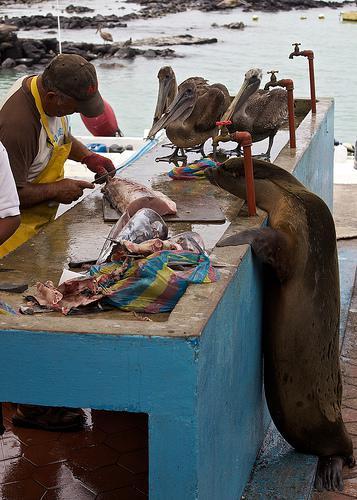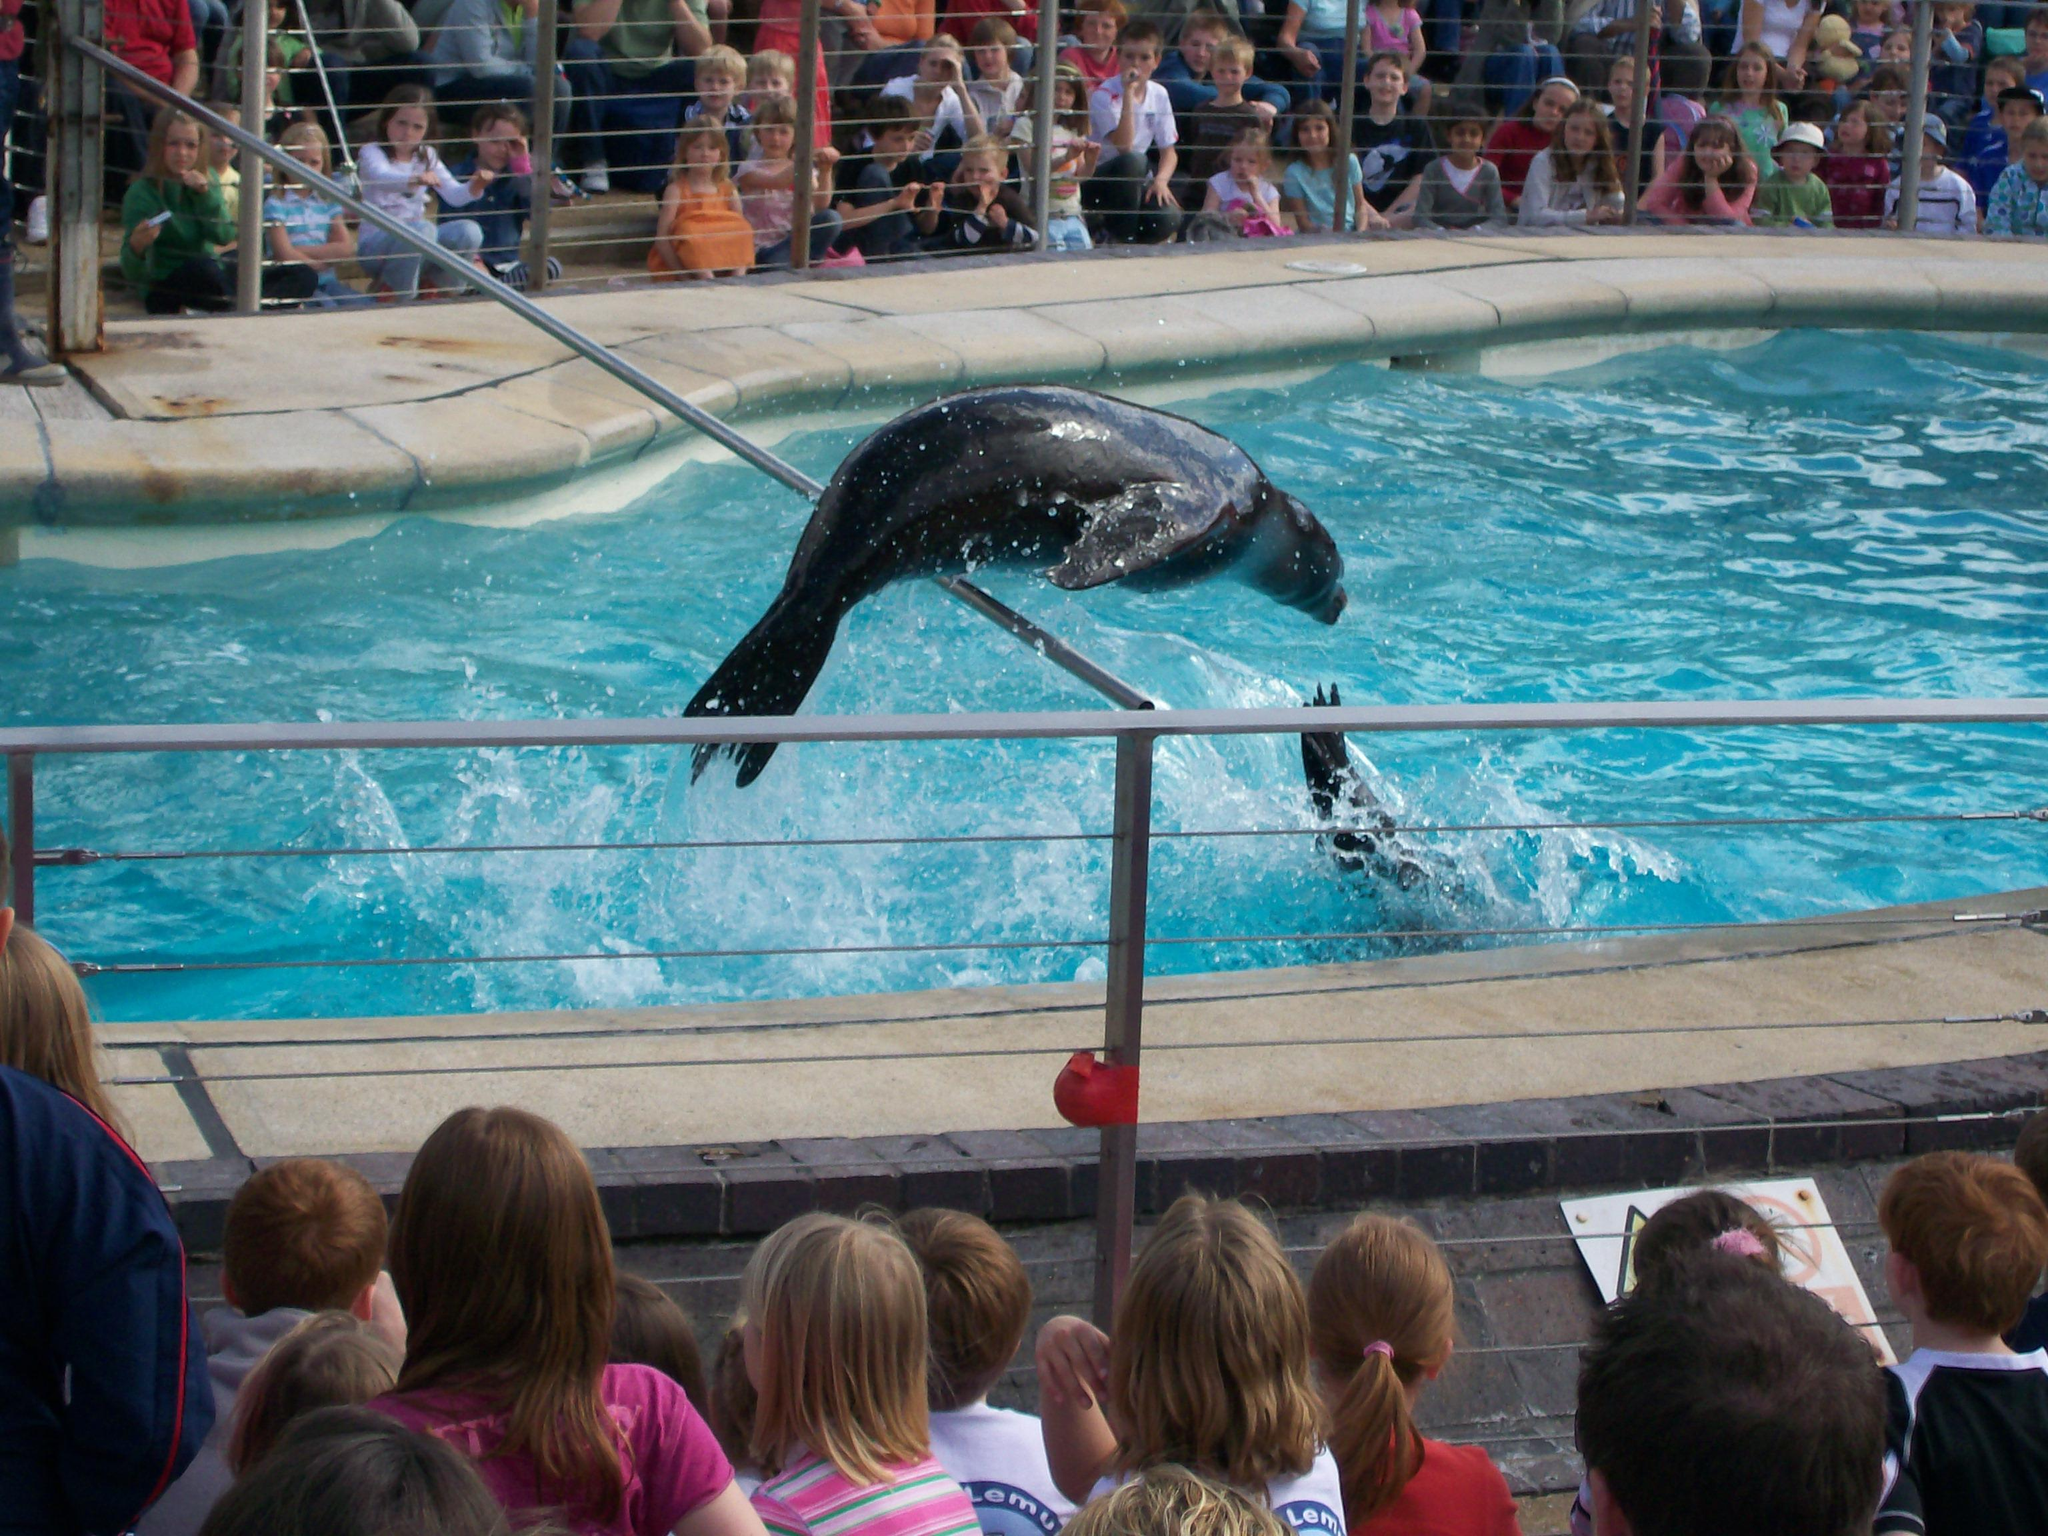The first image is the image on the left, the second image is the image on the right. Assess this claim about the two images: "Each image shows a seal performing in a show, and one image shows a seal balancing on a stone ledge with at least part of its body held in the air.". Correct or not? Answer yes or no. No. 